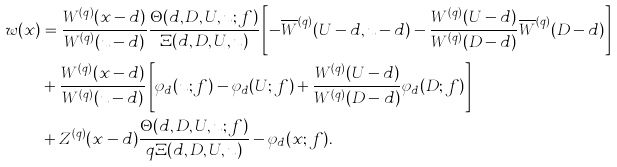<formula> <loc_0><loc_0><loc_500><loc_500>w ( x ) & = \frac { W ^ { ( q ) } ( x - d ) } { W ^ { ( q ) } ( u - d ) } \frac { \Theta ( d , D , U , u ; f ) } { \Xi ( d , D , U , u ) } \left [ - \overline { W } ^ { ( q ) } ( U - d , u - d ) - \frac { W ^ { ( q ) } ( U - d ) } { W ^ { ( q ) } ( D - d ) } \overline { W } ^ { ( q ) } ( D - d ) \right ] \\ & + \frac { W ^ { ( q ) } ( x - d ) } { W ^ { ( q ) } ( u - d ) } \left [ \varphi _ { d } ( u ; f ) - \varphi _ { d } ( U ; f ) + \frac { W ^ { ( q ) } ( U - d ) } { W ^ { ( q ) } ( D - d ) } \varphi _ { d } ( D ; f ) \right ] \\ & + Z ^ { ( q ) } ( x - d ) \frac { \Theta ( d , D , U , u ; f ) } { q \Xi ( d , D , U , u ) } - \varphi _ { d } ( x ; f ) .</formula> 